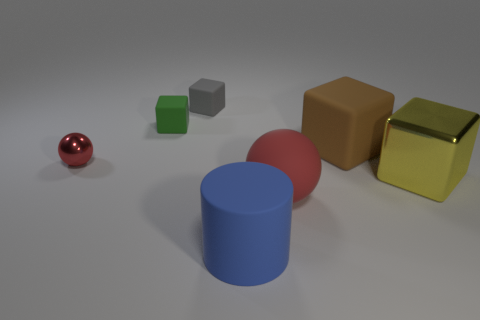There is a yellow metallic block behind the blue rubber thing; is its size the same as the brown matte object?
Ensure brevity in your answer.  Yes. There is a red object behind the big yellow shiny block; what is it made of?
Provide a short and direct response. Metal. Are there the same number of small gray cubes that are behind the large rubber sphere and large rubber objects behind the big blue object?
Your answer should be compact. No. There is another big metal object that is the same shape as the big brown thing; what is its color?
Provide a short and direct response. Yellow. Is there any other thing of the same color as the rubber cylinder?
Your answer should be compact. No. How many matte objects are blue cylinders or balls?
Offer a very short reply. 2. Does the big metal thing have the same color as the big matte ball?
Keep it short and to the point. No. Are there more small things that are in front of the large blue cylinder than brown matte things?
Make the answer very short. No. How many other objects are there of the same material as the large yellow cube?
Your answer should be very brief. 1. How many small objects are either green cylinders or matte spheres?
Ensure brevity in your answer.  0. 